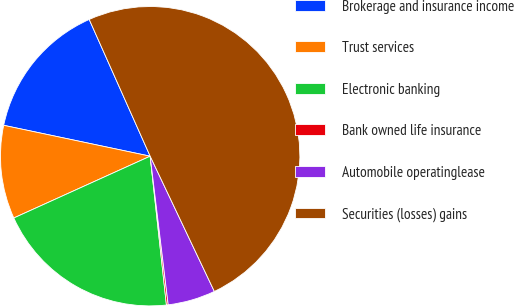Convert chart to OTSL. <chart><loc_0><loc_0><loc_500><loc_500><pie_chart><fcel>Brokerage and insurance income<fcel>Trust services<fcel>Electronic banking<fcel>Bank owned life insurance<fcel>Automobile operatinglease<fcel>Securities (losses) gains<nl><fcel>15.02%<fcel>10.08%<fcel>19.96%<fcel>0.19%<fcel>5.13%<fcel>49.62%<nl></chart> 